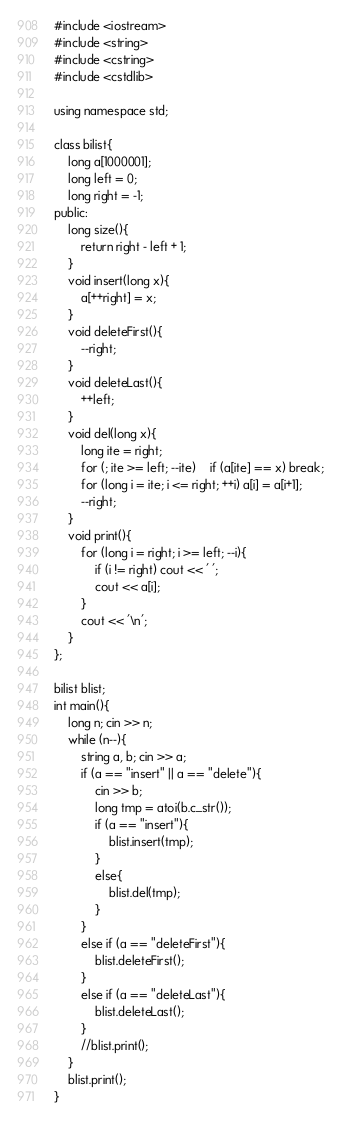Convert code to text. <code><loc_0><loc_0><loc_500><loc_500><_C++_>#include <iostream>
#include <string>
#include <cstring>
#include <cstdlib>

using namespace std;

class bilist{
	long a[1000001];
	long left = 0;
	long right = -1;
public:
	long size(){
		return right - left + 1;
	}
	void insert(long x){
		a[++right] = x;
	}
	void deleteFirst(){
		--right;
	}
	void deleteLast(){
		++left;
	}
	void del(long x){
		long ite = right;
		for (; ite >= left; --ite)	if (a[ite] == x) break;
		for (long i = ite; i <= right; ++i) a[i] = a[i+1];
		--right;
	}
	void print(){
		for (long i = right; i >= left; --i){
			if (i != right) cout << ' ';
			cout << a[i];
		}
		cout << '\n';
	}
};

bilist blist;
int main(){
	long n; cin >> n;
	while (n--){
		string a, b; cin >> a;
		if (a == "insert" || a == "delete"){
			cin >> b;
			long tmp = atoi(b.c_str());
			if (a == "insert"){
				blist.insert(tmp);
			}
			else{
				blist.del(tmp);
			}
		}
		else if (a == "deleteFirst"){
			blist.deleteFirst();
		}
		else if (a == "deleteLast"){
			blist.deleteLast();
		}
		//blist.print();
	}
	blist.print();
}</code> 